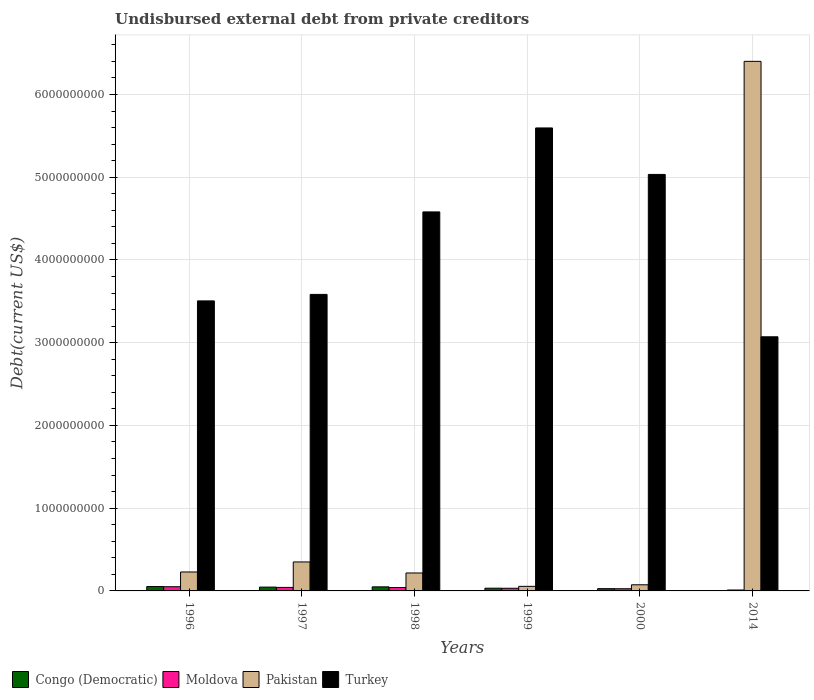Are the number of bars per tick equal to the number of legend labels?
Make the answer very short. Yes. Are the number of bars on each tick of the X-axis equal?
Give a very brief answer. Yes. How many bars are there on the 4th tick from the left?
Keep it short and to the point. 4. What is the label of the 1st group of bars from the left?
Your answer should be very brief. 1996. What is the total debt in Pakistan in 1997?
Keep it short and to the point. 3.50e+08. Across all years, what is the maximum total debt in Moldova?
Your response must be concise. 5.08e+07. Across all years, what is the minimum total debt in Moldova?
Offer a terse response. 1.11e+07. In which year was the total debt in Moldova maximum?
Your answer should be very brief. 1996. What is the total total debt in Turkey in the graph?
Provide a succinct answer. 2.54e+1. What is the difference between the total debt in Moldova in 1997 and that in 2014?
Offer a terse response. 3.14e+07. What is the difference between the total debt in Turkey in 2000 and the total debt in Moldova in 1998?
Provide a short and direct response. 4.99e+09. What is the average total debt in Moldova per year?
Your response must be concise. 3.40e+07. In the year 2000, what is the difference between the total debt in Turkey and total debt in Moldova?
Keep it short and to the point. 5.01e+09. In how many years, is the total debt in Congo (Democratic) greater than 5000000000 US$?
Your response must be concise. 0. What is the ratio of the total debt in Turkey in 1998 to that in 2000?
Your answer should be very brief. 0.91. Is the total debt in Turkey in 1999 less than that in 2000?
Your answer should be compact. No. What is the difference between the highest and the second highest total debt in Moldova?
Offer a terse response. 8.36e+06. What is the difference between the highest and the lowest total debt in Pakistan?
Offer a very short reply. 6.34e+09. What does the 2nd bar from the left in 1999 represents?
Keep it short and to the point. Moldova. What does the 2nd bar from the right in 2014 represents?
Provide a succinct answer. Pakistan. Are all the bars in the graph horizontal?
Your answer should be very brief. No. How many years are there in the graph?
Your answer should be compact. 6. What is the difference between two consecutive major ticks on the Y-axis?
Offer a very short reply. 1.00e+09. Are the values on the major ticks of Y-axis written in scientific E-notation?
Your response must be concise. No. Does the graph contain any zero values?
Ensure brevity in your answer.  No. Does the graph contain grids?
Ensure brevity in your answer.  Yes. Where does the legend appear in the graph?
Provide a short and direct response. Bottom left. What is the title of the graph?
Give a very brief answer. Undisbursed external debt from private creditors. Does "Virgin Islands" appear as one of the legend labels in the graph?
Keep it short and to the point. No. What is the label or title of the X-axis?
Keep it short and to the point. Years. What is the label or title of the Y-axis?
Your answer should be compact. Debt(current US$). What is the Debt(current US$) in Congo (Democratic) in 1996?
Give a very brief answer. 5.28e+07. What is the Debt(current US$) in Moldova in 1996?
Provide a short and direct response. 5.08e+07. What is the Debt(current US$) in Pakistan in 1996?
Provide a succinct answer. 2.29e+08. What is the Debt(current US$) in Turkey in 1996?
Keep it short and to the point. 3.51e+09. What is the Debt(current US$) in Congo (Democratic) in 1997?
Your answer should be compact. 4.61e+07. What is the Debt(current US$) in Moldova in 1997?
Your answer should be compact. 4.24e+07. What is the Debt(current US$) in Pakistan in 1997?
Offer a very short reply. 3.50e+08. What is the Debt(current US$) of Turkey in 1997?
Ensure brevity in your answer.  3.58e+09. What is the Debt(current US$) in Congo (Democratic) in 1998?
Provide a succinct answer. 4.92e+07. What is the Debt(current US$) in Moldova in 1998?
Ensure brevity in your answer.  4.11e+07. What is the Debt(current US$) of Pakistan in 1998?
Ensure brevity in your answer.  2.17e+08. What is the Debt(current US$) of Turkey in 1998?
Provide a short and direct response. 4.58e+09. What is the Debt(current US$) in Congo (Democratic) in 1999?
Offer a terse response. 3.30e+07. What is the Debt(current US$) in Moldova in 1999?
Provide a short and direct response. 3.21e+07. What is the Debt(current US$) in Pakistan in 1999?
Make the answer very short. 5.53e+07. What is the Debt(current US$) of Turkey in 1999?
Offer a very short reply. 5.60e+09. What is the Debt(current US$) of Congo (Democratic) in 2000?
Your answer should be very brief. 2.74e+07. What is the Debt(current US$) of Moldova in 2000?
Your answer should be very brief. 2.64e+07. What is the Debt(current US$) of Pakistan in 2000?
Your response must be concise. 7.41e+07. What is the Debt(current US$) of Turkey in 2000?
Provide a succinct answer. 5.03e+09. What is the Debt(current US$) in Congo (Democratic) in 2014?
Your answer should be very brief. 2.92e+06. What is the Debt(current US$) of Moldova in 2014?
Your answer should be very brief. 1.11e+07. What is the Debt(current US$) of Pakistan in 2014?
Give a very brief answer. 6.40e+09. What is the Debt(current US$) of Turkey in 2014?
Offer a terse response. 3.07e+09. Across all years, what is the maximum Debt(current US$) of Congo (Democratic)?
Your answer should be very brief. 5.28e+07. Across all years, what is the maximum Debt(current US$) in Moldova?
Your answer should be very brief. 5.08e+07. Across all years, what is the maximum Debt(current US$) of Pakistan?
Your answer should be very brief. 6.40e+09. Across all years, what is the maximum Debt(current US$) of Turkey?
Provide a succinct answer. 5.60e+09. Across all years, what is the minimum Debt(current US$) of Congo (Democratic)?
Offer a terse response. 2.92e+06. Across all years, what is the minimum Debt(current US$) of Moldova?
Keep it short and to the point. 1.11e+07. Across all years, what is the minimum Debt(current US$) of Pakistan?
Your answer should be compact. 5.53e+07. Across all years, what is the minimum Debt(current US$) in Turkey?
Ensure brevity in your answer.  3.07e+09. What is the total Debt(current US$) of Congo (Democratic) in the graph?
Keep it short and to the point. 2.11e+08. What is the total Debt(current US$) of Moldova in the graph?
Offer a terse response. 2.04e+08. What is the total Debt(current US$) of Pakistan in the graph?
Your response must be concise. 7.33e+09. What is the total Debt(current US$) in Turkey in the graph?
Ensure brevity in your answer.  2.54e+1. What is the difference between the Debt(current US$) of Congo (Democratic) in 1996 and that in 1997?
Give a very brief answer. 6.72e+06. What is the difference between the Debt(current US$) in Moldova in 1996 and that in 1997?
Make the answer very short. 8.36e+06. What is the difference between the Debt(current US$) in Pakistan in 1996 and that in 1997?
Provide a short and direct response. -1.21e+08. What is the difference between the Debt(current US$) of Turkey in 1996 and that in 1997?
Your answer should be very brief. -7.86e+07. What is the difference between the Debt(current US$) in Congo (Democratic) in 1996 and that in 1998?
Offer a terse response. 3.69e+06. What is the difference between the Debt(current US$) of Moldova in 1996 and that in 1998?
Your response must be concise. 9.63e+06. What is the difference between the Debt(current US$) in Pakistan in 1996 and that in 1998?
Ensure brevity in your answer.  1.21e+07. What is the difference between the Debt(current US$) of Turkey in 1996 and that in 1998?
Keep it short and to the point. -1.08e+09. What is the difference between the Debt(current US$) in Congo (Democratic) in 1996 and that in 1999?
Your answer should be compact. 1.99e+07. What is the difference between the Debt(current US$) in Moldova in 1996 and that in 1999?
Give a very brief answer. 1.86e+07. What is the difference between the Debt(current US$) in Pakistan in 1996 and that in 1999?
Make the answer very short. 1.74e+08. What is the difference between the Debt(current US$) of Turkey in 1996 and that in 1999?
Your answer should be compact. -2.09e+09. What is the difference between the Debt(current US$) of Congo (Democratic) in 1996 and that in 2000?
Keep it short and to the point. 2.54e+07. What is the difference between the Debt(current US$) in Moldova in 1996 and that in 2000?
Ensure brevity in your answer.  2.44e+07. What is the difference between the Debt(current US$) of Pakistan in 1996 and that in 2000?
Your answer should be very brief. 1.55e+08. What is the difference between the Debt(current US$) of Turkey in 1996 and that in 2000?
Provide a short and direct response. -1.53e+09. What is the difference between the Debt(current US$) in Congo (Democratic) in 1996 and that in 2014?
Keep it short and to the point. 4.99e+07. What is the difference between the Debt(current US$) of Moldova in 1996 and that in 2014?
Offer a terse response. 3.97e+07. What is the difference between the Debt(current US$) of Pakistan in 1996 and that in 2014?
Provide a short and direct response. -6.17e+09. What is the difference between the Debt(current US$) of Turkey in 1996 and that in 2014?
Your response must be concise. 4.34e+08. What is the difference between the Debt(current US$) of Congo (Democratic) in 1997 and that in 1998?
Your response must be concise. -3.03e+06. What is the difference between the Debt(current US$) of Moldova in 1997 and that in 1998?
Provide a short and direct response. 1.27e+06. What is the difference between the Debt(current US$) in Pakistan in 1997 and that in 1998?
Your answer should be very brief. 1.33e+08. What is the difference between the Debt(current US$) of Turkey in 1997 and that in 1998?
Offer a very short reply. -9.97e+08. What is the difference between the Debt(current US$) in Congo (Democratic) in 1997 and that in 1999?
Your response must be concise. 1.31e+07. What is the difference between the Debt(current US$) in Moldova in 1997 and that in 1999?
Ensure brevity in your answer.  1.03e+07. What is the difference between the Debt(current US$) of Pakistan in 1997 and that in 1999?
Your answer should be compact. 2.95e+08. What is the difference between the Debt(current US$) in Turkey in 1997 and that in 1999?
Offer a terse response. -2.01e+09. What is the difference between the Debt(current US$) in Congo (Democratic) in 1997 and that in 2000?
Your answer should be compact. 1.87e+07. What is the difference between the Debt(current US$) of Moldova in 1997 and that in 2000?
Ensure brevity in your answer.  1.60e+07. What is the difference between the Debt(current US$) in Pakistan in 1997 and that in 2000?
Your answer should be very brief. 2.76e+08. What is the difference between the Debt(current US$) in Turkey in 1997 and that in 2000?
Your response must be concise. -1.45e+09. What is the difference between the Debt(current US$) of Congo (Democratic) in 1997 and that in 2014?
Offer a very short reply. 4.32e+07. What is the difference between the Debt(current US$) in Moldova in 1997 and that in 2014?
Provide a short and direct response. 3.14e+07. What is the difference between the Debt(current US$) of Pakistan in 1997 and that in 2014?
Your answer should be compact. -6.05e+09. What is the difference between the Debt(current US$) in Turkey in 1997 and that in 2014?
Offer a terse response. 5.12e+08. What is the difference between the Debt(current US$) of Congo (Democratic) in 1998 and that in 1999?
Give a very brief answer. 1.62e+07. What is the difference between the Debt(current US$) of Moldova in 1998 and that in 1999?
Offer a terse response. 9.01e+06. What is the difference between the Debt(current US$) in Pakistan in 1998 and that in 1999?
Ensure brevity in your answer.  1.62e+08. What is the difference between the Debt(current US$) in Turkey in 1998 and that in 1999?
Your response must be concise. -1.01e+09. What is the difference between the Debt(current US$) of Congo (Democratic) in 1998 and that in 2000?
Your answer should be very brief. 2.18e+07. What is the difference between the Debt(current US$) in Moldova in 1998 and that in 2000?
Your response must be concise. 1.47e+07. What is the difference between the Debt(current US$) of Pakistan in 1998 and that in 2000?
Make the answer very short. 1.43e+08. What is the difference between the Debt(current US$) in Turkey in 1998 and that in 2000?
Ensure brevity in your answer.  -4.53e+08. What is the difference between the Debt(current US$) in Congo (Democratic) in 1998 and that in 2014?
Provide a succinct answer. 4.62e+07. What is the difference between the Debt(current US$) of Moldova in 1998 and that in 2014?
Offer a very short reply. 3.01e+07. What is the difference between the Debt(current US$) in Pakistan in 1998 and that in 2014?
Offer a very short reply. -6.18e+09. What is the difference between the Debt(current US$) of Turkey in 1998 and that in 2014?
Provide a short and direct response. 1.51e+09. What is the difference between the Debt(current US$) in Congo (Democratic) in 1999 and that in 2000?
Your answer should be very brief. 5.57e+06. What is the difference between the Debt(current US$) of Moldova in 1999 and that in 2000?
Provide a succinct answer. 5.72e+06. What is the difference between the Debt(current US$) of Pakistan in 1999 and that in 2000?
Offer a terse response. -1.88e+07. What is the difference between the Debt(current US$) of Turkey in 1999 and that in 2000?
Your answer should be very brief. 5.62e+08. What is the difference between the Debt(current US$) of Congo (Democratic) in 1999 and that in 2014?
Give a very brief answer. 3.01e+07. What is the difference between the Debt(current US$) of Moldova in 1999 and that in 2014?
Provide a short and direct response. 2.11e+07. What is the difference between the Debt(current US$) of Pakistan in 1999 and that in 2014?
Your answer should be very brief. -6.34e+09. What is the difference between the Debt(current US$) in Turkey in 1999 and that in 2014?
Your answer should be very brief. 2.52e+09. What is the difference between the Debt(current US$) in Congo (Democratic) in 2000 and that in 2014?
Keep it short and to the point. 2.45e+07. What is the difference between the Debt(current US$) in Moldova in 2000 and that in 2014?
Offer a terse response. 1.54e+07. What is the difference between the Debt(current US$) of Pakistan in 2000 and that in 2014?
Your answer should be very brief. -6.33e+09. What is the difference between the Debt(current US$) of Turkey in 2000 and that in 2014?
Provide a succinct answer. 1.96e+09. What is the difference between the Debt(current US$) of Congo (Democratic) in 1996 and the Debt(current US$) of Moldova in 1997?
Your answer should be very brief. 1.04e+07. What is the difference between the Debt(current US$) of Congo (Democratic) in 1996 and the Debt(current US$) of Pakistan in 1997?
Make the answer very short. -2.97e+08. What is the difference between the Debt(current US$) in Congo (Democratic) in 1996 and the Debt(current US$) in Turkey in 1997?
Give a very brief answer. -3.53e+09. What is the difference between the Debt(current US$) of Moldova in 1996 and the Debt(current US$) of Pakistan in 1997?
Offer a terse response. -2.99e+08. What is the difference between the Debt(current US$) in Moldova in 1996 and the Debt(current US$) in Turkey in 1997?
Offer a terse response. -3.53e+09. What is the difference between the Debt(current US$) of Pakistan in 1996 and the Debt(current US$) of Turkey in 1997?
Give a very brief answer. -3.35e+09. What is the difference between the Debt(current US$) in Congo (Democratic) in 1996 and the Debt(current US$) in Moldova in 1998?
Your answer should be very brief. 1.17e+07. What is the difference between the Debt(current US$) of Congo (Democratic) in 1996 and the Debt(current US$) of Pakistan in 1998?
Provide a short and direct response. -1.64e+08. What is the difference between the Debt(current US$) in Congo (Democratic) in 1996 and the Debt(current US$) in Turkey in 1998?
Keep it short and to the point. -4.53e+09. What is the difference between the Debt(current US$) in Moldova in 1996 and the Debt(current US$) in Pakistan in 1998?
Provide a short and direct response. -1.66e+08. What is the difference between the Debt(current US$) of Moldova in 1996 and the Debt(current US$) of Turkey in 1998?
Provide a short and direct response. -4.53e+09. What is the difference between the Debt(current US$) of Pakistan in 1996 and the Debt(current US$) of Turkey in 1998?
Your answer should be very brief. -4.35e+09. What is the difference between the Debt(current US$) of Congo (Democratic) in 1996 and the Debt(current US$) of Moldova in 1999?
Your answer should be very brief. 2.07e+07. What is the difference between the Debt(current US$) of Congo (Democratic) in 1996 and the Debt(current US$) of Pakistan in 1999?
Your response must be concise. -2.46e+06. What is the difference between the Debt(current US$) in Congo (Democratic) in 1996 and the Debt(current US$) in Turkey in 1999?
Your response must be concise. -5.54e+09. What is the difference between the Debt(current US$) in Moldova in 1996 and the Debt(current US$) in Pakistan in 1999?
Your response must be concise. -4.53e+06. What is the difference between the Debt(current US$) in Moldova in 1996 and the Debt(current US$) in Turkey in 1999?
Keep it short and to the point. -5.54e+09. What is the difference between the Debt(current US$) in Pakistan in 1996 and the Debt(current US$) in Turkey in 1999?
Provide a succinct answer. -5.37e+09. What is the difference between the Debt(current US$) in Congo (Democratic) in 1996 and the Debt(current US$) in Moldova in 2000?
Ensure brevity in your answer.  2.64e+07. What is the difference between the Debt(current US$) of Congo (Democratic) in 1996 and the Debt(current US$) of Pakistan in 2000?
Provide a succinct answer. -2.12e+07. What is the difference between the Debt(current US$) of Congo (Democratic) in 1996 and the Debt(current US$) of Turkey in 2000?
Ensure brevity in your answer.  -4.98e+09. What is the difference between the Debt(current US$) of Moldova in 1996 and the Debt(current US$) of Pakistan in 2000?
Provide a short and direct response. -2.33e+07. What is the difference between the Debt(current US$) of Moldova in 1996 and the Debt(current US$) of Turkey in 2000?
Provide a succinct answer. -4.98e+09. What is the difference between the Debt(current US$) in Pakistan in 1996 and the Debt(current US$) in Turkey in 2000?
Offer a terse response. -4.80e+09. What is the difference between the Debt(current US$) in Congo (Democratic) in 1996 and the Debt(current US$) in Moldova in 2014?
Provide a succinct answer. 4.18e+07. What is the difference between the Debt(current US$) in Congo (Democratic) in 1996 and the Debt(current US$) in Pakistan in 2014?
Offer a very short reply. -6.35e+09. What is the difference between the Debt(current US$) in Congo (Democratic) in 1996 and the Debt(current US$) in Turkey in 2014?
Provide a short and direct response. -3.02e+09. What is the difference between the Debt(current US$) in Moldova in 1996 and the Debt(current US$) in Pakistan in 2014?
Your answer should be compact. -6.35e+09. What is the difference between the Debt(current US$) in Moldova in 1996 and the Debt(current US$) in Turkey in 2014?
Ensure brevity in your answer.  -3.02e+09. What is the difference between the Debt(current US$) of Pakistan in 1996 and the Debt(current US$) of Turkey in 2014?
Give a very brief answer. -2.84e+09. What is the difference between the Debt(current US$) of Congo (Democratic) in 1997 and the Debt(current US$) of Moldova in 1998?
Your response must be concise. 4.99e+06. What is the difference between the Debt(current US$) in Congo (Democratic) in 1997 and the Debt(current US$) in Pakistan in 1998?
Provide a succinct answer. -1.71e+08. What is the difference between the Debt(current US$) in Congo (Democratic) in 1997 and the Debt(current US$) in Turkey in 1998?
Your answer should be compact. -4.53e+09. What is the difference between the Debt(current US$) of Moldova in 1997 and the Debt(current US$) of Pakistan in 1998?
Provide a succinct answer. -1.74e+08. What is the difference between the Debt(current US$) of Moldova in 1997 and the Debt(current US$) of Turkey in 1998?
Offer a very short reply. -4.54e+09. What is the difference between the Debt(current US$) of Pakistan in 1997 and the Debt(current US$) of Turkey in 1998?
Make the answer very short. -4.23e+09. What is the difference between the Debt(current US$) of Congo (Democratic) in 1997 and the Debt(current US$) of Moldova in 1999?
Your response must be concise. 1.40e+07. What is the difference between the Debt(current US$) of Congo (Democratic) in 1997 and the Debt(current US$) of Pakistan in 1999?
Your response must be concise. -9.18e+06. What is the difference between the Debt(current US$) in Congo (Democratic) in 1997 and the Debt(current US$) in Turkey in 1999?
Ensure brevity in your answer.  -5.55e+09. What is the difference between the Debt(current US$) in Moldova in 1997 and the Debt(current US$) in Pakistan in 1999?
Your answer should be very brief. -1.29e+07. What is the difference between the Debt(current US$) of Moldova in 1997 and the Debt(current US$) of Turkey in 1999?
Your answer should be very brief. -5.55e+09. What is the difference between the Debt(current US$) in Pakistan in 1997 and the Debt(current US$) in Turkey in 1999?
Offer a terse response. -5.25e+09. What is the difference between the Debt(current US$) of Congo (Democratic) in 1997 and the Debt(current US$) of Moldova in 2000?
Your answer should be compact. 1.97e+07. What is the difference between the Debt(current US$) of Congo (Democratic) in 1997 and the Debt(current US$) of Pakistan in 2000?
Provide a short and direct response. -2.80e+07. What is the difference between the Debt(current US$) in Congo (Democratic) in 1997 and the Debt(current US$) in Turkey in 2000?
Give a very brief answer. -4.99e+09. What is the difference between the Debt(current US$) of Moldova in 1997 and the Debt(current US$) of Pakistan in 2000?
Your answer should be very brief. -3.17e+07. What is the difference between the Debt(current US$) in Moldova in 1997 and the Debt(current US$) in Turkey in 2000?
Offer a very short reply. -4.99e+09. What is the difference between the Debt(current US$) of Pakistan in 1997 and the Debt(current US$) of Turkey in 2000?
Make the answer very short. -4.68e+09. What is the difference between the Debt(current US$) in Congo (Democratic) in 1997 and the Debt(current US$) in Moldova in 2014?
Your answer should be compact. 3.51e+07. What is the difference between the Debt(current US$) in Congo (Democratic) in 1997 and the Debt(current US$) in Pakistan in 2014?
Keep it short and to the point. -6.35e+09. What is the difference between the Debt(current US$) in Congo (Democratic) in 1997 and the Debt(current US$) in Turkey in 2014?
Provide a succinct answer. -3.03e+09. What is the difference between the Debt(current US$) in Moldova in 1997 and the Debt(current US$) in Pakistan in 2014?
Your answer should be very brief. -6.36e+09. What is the difference between the Debt(current US$) in Moldova in 1997 and the Debt(current US$) in Turkey in 2014?
Provide a short and direct response. -3.03e+09. What is the difference between the Debt(current US$) of Pakistan in 1997 and the Debt(current US$) of Turkey in 2014?
Ensure brevity in your answer.  -2.72e+09. What is the difference between the Debt(current US$) in Congo (Democratic) in 1998 and the Debt(current US$) in Moldova in 1999?
Offer a very short reply. 1.70e+07. What is the difference between the Debt(current US$) in Congo (Democratic) in 1998 and the Debt(current US$) in Pakistan in 1999?
Your response must be concise. -6.15e+06. What is the difference between the Debt(current US$) in Congo (Democratic) in 1998 and the Debt(current US$) in Turkey in 1999?
Make the answer very short. -5.55e+09. What is the difference between the Debt(current US$) of Moldova in 1998 and the Debt(current US$) of Pakistan in 1999?
Offer a terse response. -1.42e+07. What is the difference between the Debt(current US$) of Moldova in 1998 and the Debt(current US$) of Turkey in 1999?
Your answer should be very brief. -5.55e+09. What is the difference between the Debt(current US$) in Pakistan in 1998 and the Debt(current US$) in Turkey in 1999?
Provide a short and direct response. -5.38e+09. What is the difference between the Debt(current US$) in Congo (Democratic) in 1998 and the Debt(current US$) in Moldova in 2000?
Offer a very short reply. 2.27e+07. What is the difference between the Debt(current US$) in Congo (Democratic) in 1998 and the Debt(current US$) in Pakistan in 2000?
Ensure brevity in your answer.  -2.49e+07. What is the difference between the Debt(current US$) in Congo (Democratic) in 1998 and the Debt(current US$) in Turkey in 2000?
Offer a terse response. -4.98e+09. What is the difference between the Debt(current US$) of Moldova in 1998 and the Debt(current US$) of Pakistan in 2000?
Keep it short and to the point. -3.29e+07. What is the difference between the Debt(current US$) of Moldova in 1998 and the Debt(current US$) of Turkey in 2000?
Keep it short and to the point. -4.99e+09. What is the difference between the Debt(current US$) in Pakistan in 1998 and the Debt(current US$) in Turkey in 2000?
Provide a short and direct response. -4.82e+09. What is the difference between the Debt(current US$) in Congo (Democratic) in 1998 and the Debt(current US$) in Moldova in 2014?
Offer a terse response. 3.81e+07. What is the difference between the Debt(current US$) in Congo (Democratic) in 1998 and the Debt(current US$) in Pakistan in 2014?
Offer a terse response. -6.35e+09. What is the difference between the Debt(current US$) in Congo (Democratic) in 1998 and the Debt(current US$) in Turkey in 2014?
Ensure brevity in your answer.  -3.02e+09. What is the difference between the Debt(current US$) of Moldova in 1998 and the Debt(current US$) of Pakistan in 2014?
Keep it short and to the point. -6.36e+09. What is the difference between the Debt(current US$) of Moldova in 1998 and the Debt(current US$) of Turkey in 2014?
Provide a succinct answer. -3.03e+09. What is the difference between the Debt(current US$) in Pakistan in 1998 and the Debt(current US$) in Turkey in 2014?
Ensure brevity in your answer.  -2.85e+09. What is the difference between the Debt(current US$) in Congo (Democratic) in 1999 and the Debt(current US$) in Moldova in 2000?
Provide a succinct answer. 6.57e+06. What is the difference between the Debt(current US$) of Congo (Democratic) in 1999 and the Debt(current US$) of Pakistan in 2000?
Offer a very short reply. -4.11e+07. What is the difference between the Debt(current US$) of Congo (Democratic) in 1999 and the Debt(current US$) of Turkey in 2000?
Ensure brevity in your answer.  -5.00e+09. What is the difference between the Debt(current US$) in Moldova in 1999 and the Debt(current US$) in Pakistan in 2000?
Provide a succinct answer. -4.19e+07. What is the difference between the Debt(current US$) in Moldova in 1999 and the Debt(current US$) in Turkey in 2000?
Make the answer very short. -5.00e+09. What is the difference between the Debt(current US$) of Pakistan in 1999 and the Debt(current US$) of Turkey in 2000?
Offer a very short reply. -4.98e+09. What is the difference between the Debt(current US$) in Congo (Democratic) in 1999 and the Debt(current US$) in Moldova in 2014?
Offer a very short reply. 2.19e+07. What is the difference between the Debt(current US$) in Congo (Democratic) in 1999 and the Debt(current US$) in Pakistan in 2014?
Offer a very short reply. -6.37e+09. What is the difference between the Debt(current US$) in Congo (Democratic) in 1999 and the Debt(current US$) in Turkey in 2014?
Ensure brevity in your answer.  -3.04e+09. What is the difference between the Debt(current US$) of Moldova in 1999 and the Debt(current US$) of Pakistan in 2014?
Keep it short and to the point. -6.37e+09. What is the difference between the Debt(current US$) of Moldova in 1999 and the Debt(current US$) of Turkey in 2014?
Offer a terse response. -3.04e+09. What is the difference between the Debt(current US$) in Pakistan in 1999 and the Debt(current US$) in Turkey in 2014?
Provide a short and direct response. -3.02e+09. What is the difference between the Debt(current US$) of Congo (Democratic) in 2000 and the Debt(current US$) of Moldova in 2014?
Give a very brief answer. 1.64e+07. What is the difference between the Debt(current US$) of Congo (Democratic) in 2000 and the Debt(current US$) of Pakistan in 2014?
Provide a short and direct response. -6.37e+09. What is the difference between the Debt(current US$) of Congo (Democratic) in 2000 and the Debt(current US$) of Turkey in 2014?
Keep it short and to the point. -3.04e+09. What is the difference between the Debt(current US$) in Moldova in 2000 and the Debt(current US$) in Pakistan in 2014?
Ensure brevity in your answer.  -6.37e+09. What is the difference between the Debt(current US$) of Moldova in 2000 and the Debt(current US$) of Turkey in 2014?
Your answer should be very brief. -3.04e+09. What is the difference between the Debt(current US$) in Pakistan in 2000 and the Debt(current US$) in Turkey in 2014?
Make the answer very short. -3.00e+09. What is the average Debt(current US$) of Congo (Democratic) per year?
Provide a short and direct response. 3.52e+07. What is the average Debt(current US$) in Moldova per year?
Ensure brevity in your answer.  3.40e+07. What is the average Debt(current US$) in Pakistan per year?
Provide a succinct answer. 1.22e+09. What is the average Debt(current US$) of Turkey per year?
Your response must be concise. 4.23e+09. In the year 1996, what is the difference between the Debt(current US$) of Congo (Democratic) and Debt(current US$) of Moldova?
Provide a short and direct response. 2.07e+06. In the year 1996, what is the difference between the Debt(current US$) in Congo (Democratic) and Debt(current US$) in Pakistan?
Provide a succinct answer. -1.76e+08. In the year 1996, what is the difference between the Debt(current US$) of Congo (Democratic) and Debt(current US$) of Turkey?
Your answer should be very brief. -3.45e+09. In the year 1996, what is the difference between the Debt(current US$) in Moldova and Debt(current US$) in Pakistan?
Keep it short and to the point. -1.78e+08. In the year 1996, what is the difference between the Debt(current US$) of Moldova and Debt(current US$) of Turkey?
Keep it short and to the point. -3.45e+09. In the year 1996, what is the difference between the Debt(current US$) of Pakistan and Debt(current US$) of Turkey?
Ensure brevity in your answer.  -3.28e+09. In the year 1997, what is the difference between the Debt(current US$) of Congo (Democratic) and Debt(current US$) of Moldova?
Ensure brevity in your answer.  3.72e+06. In the year 1997, what is the difference between the Debt(current US$) in Congo (Democratic) and Debt(current US$) in Pakistan?
Make the answer very short. -3.04e+08. In the year 1997, what is the difference between the Debt(current US$) of Congo (Democratic) and Debt(current US$) of Turkey?
Ensure brevity in your answer.  -3.54e+09. In the year 1997, what is the difference between the Debt(current US$) in Moldova and Debt(current US$) in Pakistan?
Your answer should be very brief. -3.08e+08. In the year 1997, what is the difference between the Debt(current US$) of Moldova and Debt(current US$) of Turkey?
Provide a short and direct response. -3.54e+09. In the year 1997, what is the difference between the Debt(current US$) of Pakistan and Debt(current US$) of Turkey?
Keep it short and to the point. -3.23e+09. In the year 1998, what is the difference between the Debt(current US$) in Congo (Democratic) and Debt(current US$) in Moldova?
Your answer should be compact. 8.02e+06. In the year 1998, what is the difference between the Debt(current US$) in Congo (Democratic) and Debt(current US$) in Pakistan?
Your answer should be very brief. -1.68e+08. In the year 1998, what is the difference between the Debt(current US$) in Congo (Democratic) and Debt(current US$) in Turkey?
Your answer should be compact. -4.53e+09. In the year 1998, what is the difference between the Debt(current US$) in Moldova and Debt(current US$) in Pakistan?
Your response must be concise. -1.76e+08. In the year 1998, what is the difference between the Debt(current US$) of Moldova and Debt(current US$) of Turkey?
Offer a very short reply. -4.54e+09. In the year 1998, what is the difference between the Debt(current US$) of Pakistan and Debt(current US$) of Turkey?
Give a very brief answer. -4.36e+09. In the year 1999, what is the difference between the Debt(current US$) in Congo (Democratic) and Debt(current US$) in Moldova?
Your response must be concise. 8.49e+05. In the year 1999, what is the difference between the Debt(current US$) of Congo (Democratic) and Debt(current US$) of Pakistan?
Keep it short and to the point. -2.23e+07. In the year 1999, what is the difference between the Debt(current US$) in Congo (Democratic) and Debt(current US$) in Turkey?
Your answer should be compact. -5.56e+09. In the year 1999, what is the difference between the Debt(current US$) in Moldova and Debt(current US$) in Pakistan?
Offer a terse response. -2.32e+07. In the year 1999, what is the difference between the Debt(current US$) of Moldova and Debt(current US$) of Turkey?
Your answer should be very brief. -5.56e+09. In the year 1999, what is the difference between the Debt(current US$) of Pakistan and Debt(current US$) of Turkey?
Offer a very short reply. -5.54e+09. In the year 2000, what is the difference between the Debt(current US$) of Congo (Democratic) and Debt(current US$) of Moldova?
Provide a short and direct response. 9.94e+05. In the year 2000, what is the difference between the Debt(current US$) of Congo (Democratic) and Debt(current US$) of Pakistan?
Ensure brevity in your answer.  -4.67e+07. In the year 2000, what is the difference between the Debt(current US$) of Congo (Democratic) and Debt(current US$) of Turkey?
Offer a terse response. -5.01e+09. In the year 2000, what is the difference between the Debt(current US$) of Moldova and Debt(current US$) of Pakistan?
Your answer should be compact. -4.77e+07. In the year 2000, what is the difference between the Debt(current US$) in Moldova and Debt(current US$) in Turkey?
Offer a terse response. -5.01e+09. In the year 2000, what is the difference between the Debt(current US$) in Pakistan and Debt(current US$) in Turkey?
Provide a succinct answer. -4.96e+09. In the year 2014, what is the difference between the Debt(current US$) of Congo (Democratic) and Debt(current US$) of Moldova?
Ensure brevity in your answer.  -8.14e+06. In the year 2014, what is the difference between the Debt(current US$) of Congo (Democratic) and Debt(current US$) of Pakistan?
Your answer should be compact. -6.40e+09. In the year 2014, what is the difference between the Debt(current US$) in Congo (Democratic) and Debt(current US$) in Turkey?
Offer a terse response. -3.07e+09. In the year 2014, what is the difference between the Debt(current US$) of Moldova and Debt(current US$) of Pakistan?
Provide a short and direct response. -6.39e+09. In the year 2014, what is the difference between the Debt(current US$) in Moldova and Debt(current US$) in Turkey?
Your answer should be very brief. -3.06e+09. In the year 2014, what is the difference between the Debt(current US$) of Pakistan and Debt(current US$) of Turkey?
Your response must be concise. 3.33e+09. What is the ratio of the Debt(current US$) of Congo (Democratic) in 1996 to that in 1997?
Make the answer very short. 1.15. What is the ratio of the Debt(current US$) in Moldova in 1996 to that in 1997?
Provide a succinct answer. 1.2. What is the ratio of the Debt(current US$) of Pakistan in 1996 to that in 1997?
Make the answer very short. 0.65. What is the ratio of the Debt(current US$) of Turkey in 1996 to that in 1997?
Provide a succinct answer. 0.98. What is the ratio of the Debt(current US$) of Congo (Democratic) in 1996 to that in 1998?
Your answer should be compact. 1.07. What is the ratio of the Debt(current US$) in Moldova in 1996 to that in 1998?
Your answer should be very brief. 1.23. What is the ratio of the Debt(current US$) of Pakistan in 1996 to that in 1998?
Offer a very short reply. 1.06. What is the ratio of the Debt(current US$) of Turkey in 1996 to that in 1998?
Ensure brevity in your answer.  0.77. What is the ratio of the Debt(current US$) in Congo (Democratic) in 1996 to that in 1999?
Give a very brief answer. 1.6. What is the ratio of the Debt(current US$) in Moldova in 1996 to that in 1999?
Your response must be concise. 1.58. What is the ratio of the Debt(current US$) of Pakistan in 1996 to that in 1999?
Provide a short and direct response. 4.14. What is the ratio of the Debt(current US$) of Turkey in 1996 to that in 1999?
Your response must be concise. 0.63. What is the ratio of the Debt(current US$) of Congo (Democratic) in 1996 to that in 2000?
Ensure brevity in your answer.  1.93. What is the ratio of the Debt(current US$) of Moldova in 1996 to that in 2000?
Give a very brief answer. 1.92. What is the ratio of the Debt(current US$) of Pakistan in 1996 to that in 2000?
Offer a very short reply. 3.09. What is the ratio of the Debt(current US$) of Turkey in 1996 to that in 2000?
Your response must be concise. 0.7. What is the ratio of the Debt(current US$) of Congo (Democratic) in 1996 to that in 2014?
Offer a very short reply. 18.1. What is the ratio of the Debt(current US$) in Moldova in 1996 to that in 2014?
Offer a terse response. 4.59. What is the ratio of the Debt(current US$) in Pakistan in 1996 to that in 2014?
Ensure brevity in your answer.  0.04. What is the ratio of the Debt(current US$) of Turkey in 1996 to that in 2014?
Ensure brevity in your answer.  1.14. What is the ratio of the Debt(current US$) in Congo (Democratic) in 1997 to that in 1998?
Provide a short and direct response. 0.94. What is the ratio of the Debt(current US$) in Moldova in 1997 to that in 1998?
Your answer should be compact. 1.03. What is the ratio of the Debt(current US$) in Pakistan in 1997 to that in 1998?
Offer a very short reply. 1.61. What is the ratio of the Debt(current US$) of Turkey in 1997 to that in 1998?
Provide a short and direct response. 0.78. What is the ratio of the Debt(current US$) of Congo (Democratic) in 1997 to that in 1999?
Offer a very short reply. 1.4. What is the ratio of the Debt(current US$) of Moldova in 1997 to that in 1999?
Make the answer very short. 1.32. What is the ratio of the Debt(current US$) in Pakistan in 1997 to that in 1999?
Provide a short and direct response. 6.33. What is the ratio of the Debt(current US$) of Turkey in 1997 to that in 1999?
Offer a very short reply. 0.64. What is the ratio of the Debt(current US$) in Congo (Democratic) in 1997 to that in 2000?
Your answer should be compact. 1.68. What is the ratio of the Debt(current US$) of Moldova in 1997 to that in 2000?
Your response must be concise. 1.61. What is the ratio of the Debt(current US$) of Pakistan in 1997 to that in 2000?
Keep it short and to the point. 4.73. What is the ratio of the Debt(current US$) of Turkey in 1997 to that in 2000?
Give a very brief answer. 0.71. What is the ratio of the Debt(current US$) of Congo (Democratic) in 1997 to that in 2014?
Offer a very short reply. 15.8. What is the ratio of the Debt(current US$) in Moldova in 1997 to that in 2014?
Make the answer very short. 3.84. What is the ratio of the Debt(current US$) of Pakistan in 1997 to that in 2014?
Make the answer very short. 0.05. What is the ratio of the Debt(current US$) of Turkey in 1997 to that in 2014?
Your response must be concise. 1.17. What is the ratio of the Debt(current US$) of Congo (Democratic) in 1998 to that in 1999?
Provide a succinct answer. 1.49. What is the ratio of the Debt(current US$) of Moldova in 1998 to that in 1999?
Your answer should be very brief. 1.28. What is the ratio of the Debt(current US$) of Pakistan in 1998 to that in 1999?
Your answer should be compact. 3.92. What is the ratio of the Debt(current US$) in Turkey in 1998 to that in 1999?
Provide a short and direct response. 0.82. What is the ratio of the Debt(current US$) of Congo (Democratic) in 1998 to that in 2000?
Provide a short and direct response. 1.79. What is the ratio of the Debt(current US$) in Moldova in 1998 to that in 2000?
Offer a terse response. 1.56. What is the ratio of the Debt(current US$) of Pakistan in 1998 to that in 2000?
Provide a short and direct response. 2.93. What is the ratio of the Debt(current US$) in Turkey in 1998 to that in 2000?
Keep it short and to the point. 0.91. What is the ratio of the Debt(current US$) in Congo (Democratic) in 1998 to that in 2014?
Ensure brevity in your answer.  16.84. What is the ratio of the Debt(current US$) of Moldova in 1998 to that in 2014?
Provide a short and direct response. 3.72. What is the ratio of the Debt(current US$) of Pakistan in 1998 to that in 2014?
Offer a terse response. 0.03. What is the ratio of the Debt(current US$) of Turkey in 1998 to that in 2014?
Keep it short and to the point. 1.49. What is the ratio of the Debt(current US$) in Congo (Democratic) in 1999 to that in 2000?
Your response must be concise. 1.2. What is the ratio of the Debt(current US$) of Moldova in 1999 to that in 2000?
Offer a very short reply. 1.22. What is the ratio of the Debt(current US$) in Pakistan in 1999 to that in 2000?
Your response must be concise. 0.75. What is the ratio of the Debt(current US$) in Turkey in 1999 to that in 2000?
Your response must be concise. 1.11. What is the ratio of the Debt(current US$) of Congo (Democratic) in 1999 to that in 2014?
Your answer should be very brief. 11.3. What is the ratio of the Debt(current US$) of Moldova in 1999 to that in 2014?
Offer a very short reply. 2.91. What is the ratio of the Debt(current US$) in Pakistan in 1999 to that in 2014?
Make the answer very short. 0.01. What is the ratio of the Debt(current US$) of Turkey in 1999 to that in 2014?
Your answer should be very brief. 1.82. What is the ratio of the Debt(current US$) of Congo (Democratic) in 2000 to that in 2014?
Your answer should be very brief. 9.39. What is the ratio of the Debt(current US$) in Moldova in 2000 to that in 2014?
Offer a terse response. 2.39. What is the ratio of the Debt(current US$) in Pakistan in 2000 to that in 2014?
Offer a terse response. 0.01. What is the ratio of the Debt(current US$) in Turkey in 2000 to that in 2014?
Offer a terse response. 1.64. What is the difference between the highest and the second highest Debt(current US$) of Congo (Democratic)?
Provide a succinct answer. 3.69e+06. What is the difference between the highest and the second highest Debt(current US$) in Moldova?
Give a very brief answer. 8.36e+06. What is the difference between the highest and the second highest Debt(current US$) of Pakistan?
Give a very brief answer. 6.05e+09. What is the difference between the highest and the second highest Debt(current US$) of Turkey?
Offer a very short reply. 5.62e+08. What is the difference between the highest and the lowest Debt(current US$) of Congo (Democratic)?
Your answer should be very brief. 4.99e+07. What is the difference between the highest and the lowest Debt(current US$) of Moldova?
Keep it short and to the point. 3.97e+07. What is the difference between the highest and the lowest Debt(current US$) of Pakistan?
Your response must be concise. 6.34e+09. What is the difference between the highest and the lowest Debt(current US$) of Turkey?
Your answer should be very brief. 2.52e+09. 